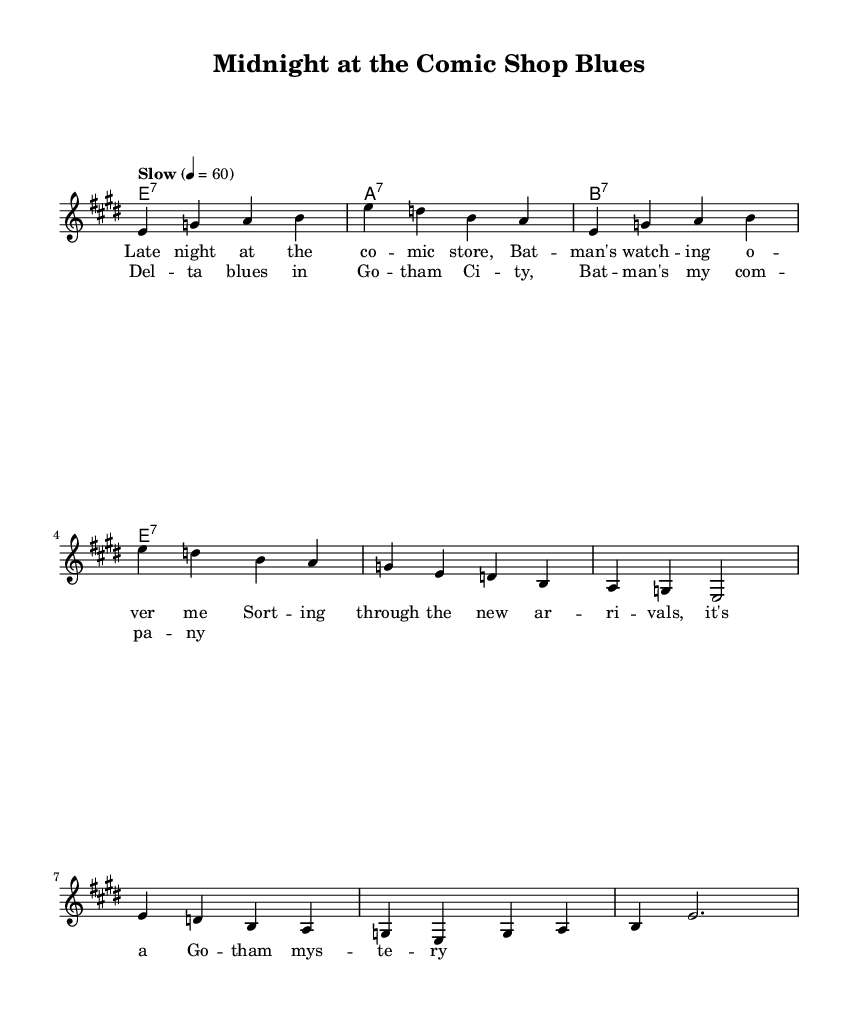What is the key signature of this music? The key signature is indicated at the beginning of the sheet music with the sharp notes. Here, it shows three sharps, which defines E major as the key.
Answer: E major What is the time signature of this music? The time signature is represented by the numbers at the beginning of the sheet music. Here, it shows 4 over 4, meaning there are four beats in each measure and the quarter note gets one beat.
Answer: 4/4 What is the tempo marking given in the music? The tempo is specified above the notation in terms of beats per minute. In this sheet music, it is marked as "Slow" with a tempo of 60 beats per minute.
Answer: Slow How many measures are in the verse section? To identify the number of measures in the verse, count each bar delineated by the vertical lines. The verse section contains a total of four measures.
Answer: Four What type of blues is reflected in this song? "Delta blues" is a specific subgenre that emphasizes the melancholic themes typical of these lyrics. The song's structure and lyrical content showcase elements identifiable with Delta blues.
Answer: Delta blues How many different chords are used in the harmonies? To ascertain the number of chords, observe the chord changes written beneath the melody. Here, the harmonies section lists three distinct chords: E7, A7, and B7.
Answer: Three What is the main lyrical theme of the song? The lyrical content can be analyzed by reading the lines of the verses. The theme focuses on the experience of working late in a comic shop, suggesting loneliness and introspection, which aligns with the blues genre's emotional depth.
Answer: Late night work 